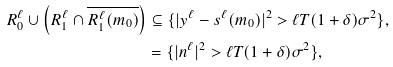<formula> <loc_0><loc_0><loc_500><loc_500>R _ { 0 } ^ { \ell } \cup \left ( R _ { 1 } ^ { \ell } \cap \overline { R _ { 1 } ^ { \ell } ( m _ { 0 } ) } \right ) & \subseteq \{ | y ^ { \ell } - s ^ { \ell } ( m _ { 0 } ) | ^ { 2 } > \ell T ( 1 + \delta ) \sigma ^ { 2 } \} , \\ & = \{ | n ^ { \ell } | ^ { 2 } > \ell T ( 1 + \delta ) \sigma ^ { 2 } \} ,</formula> 